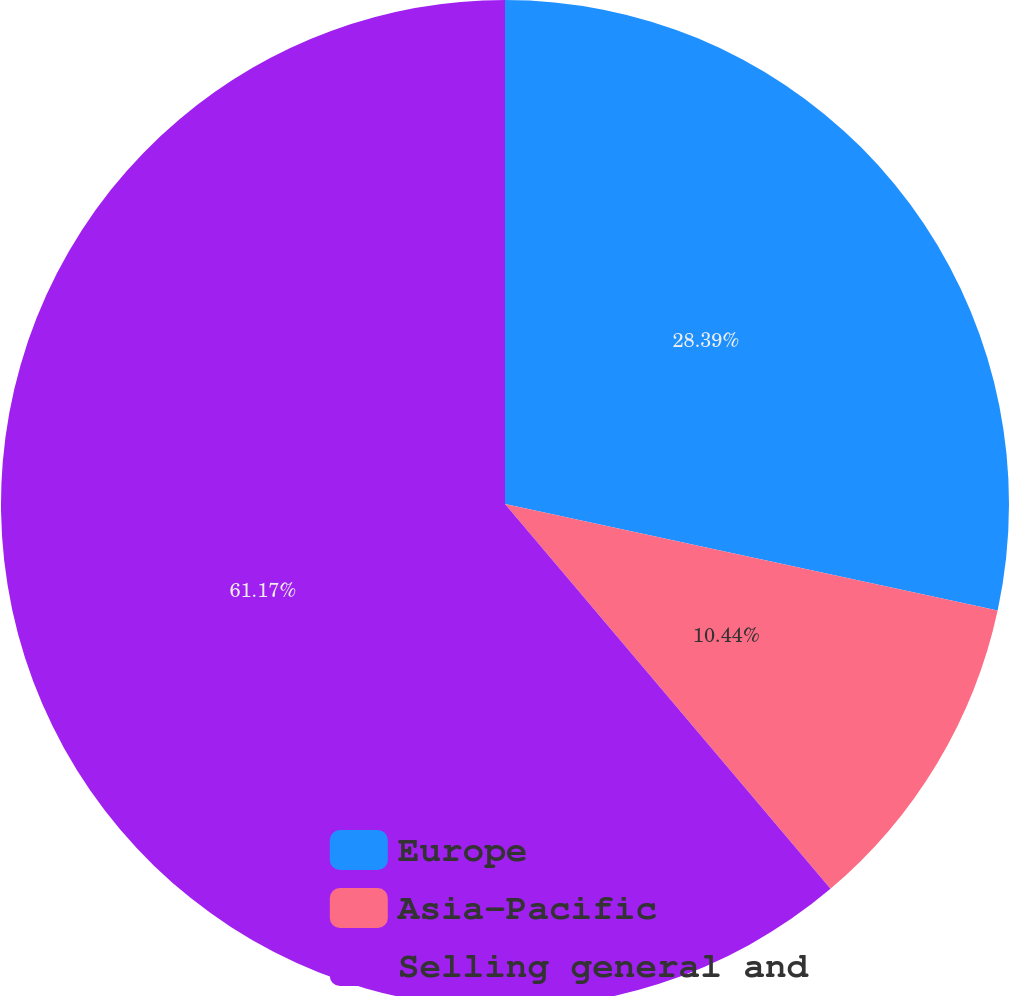Convert chart to OTSL. <chart><loc_0><loc_0><loc_500><loc_500><pie_chart><fcel>Europe<fcel>Asia-Pacific<fcel>Selling general and<nl><fcel>28.39%<fcel>10.44%<fcel>61.18%<nl></chart> 